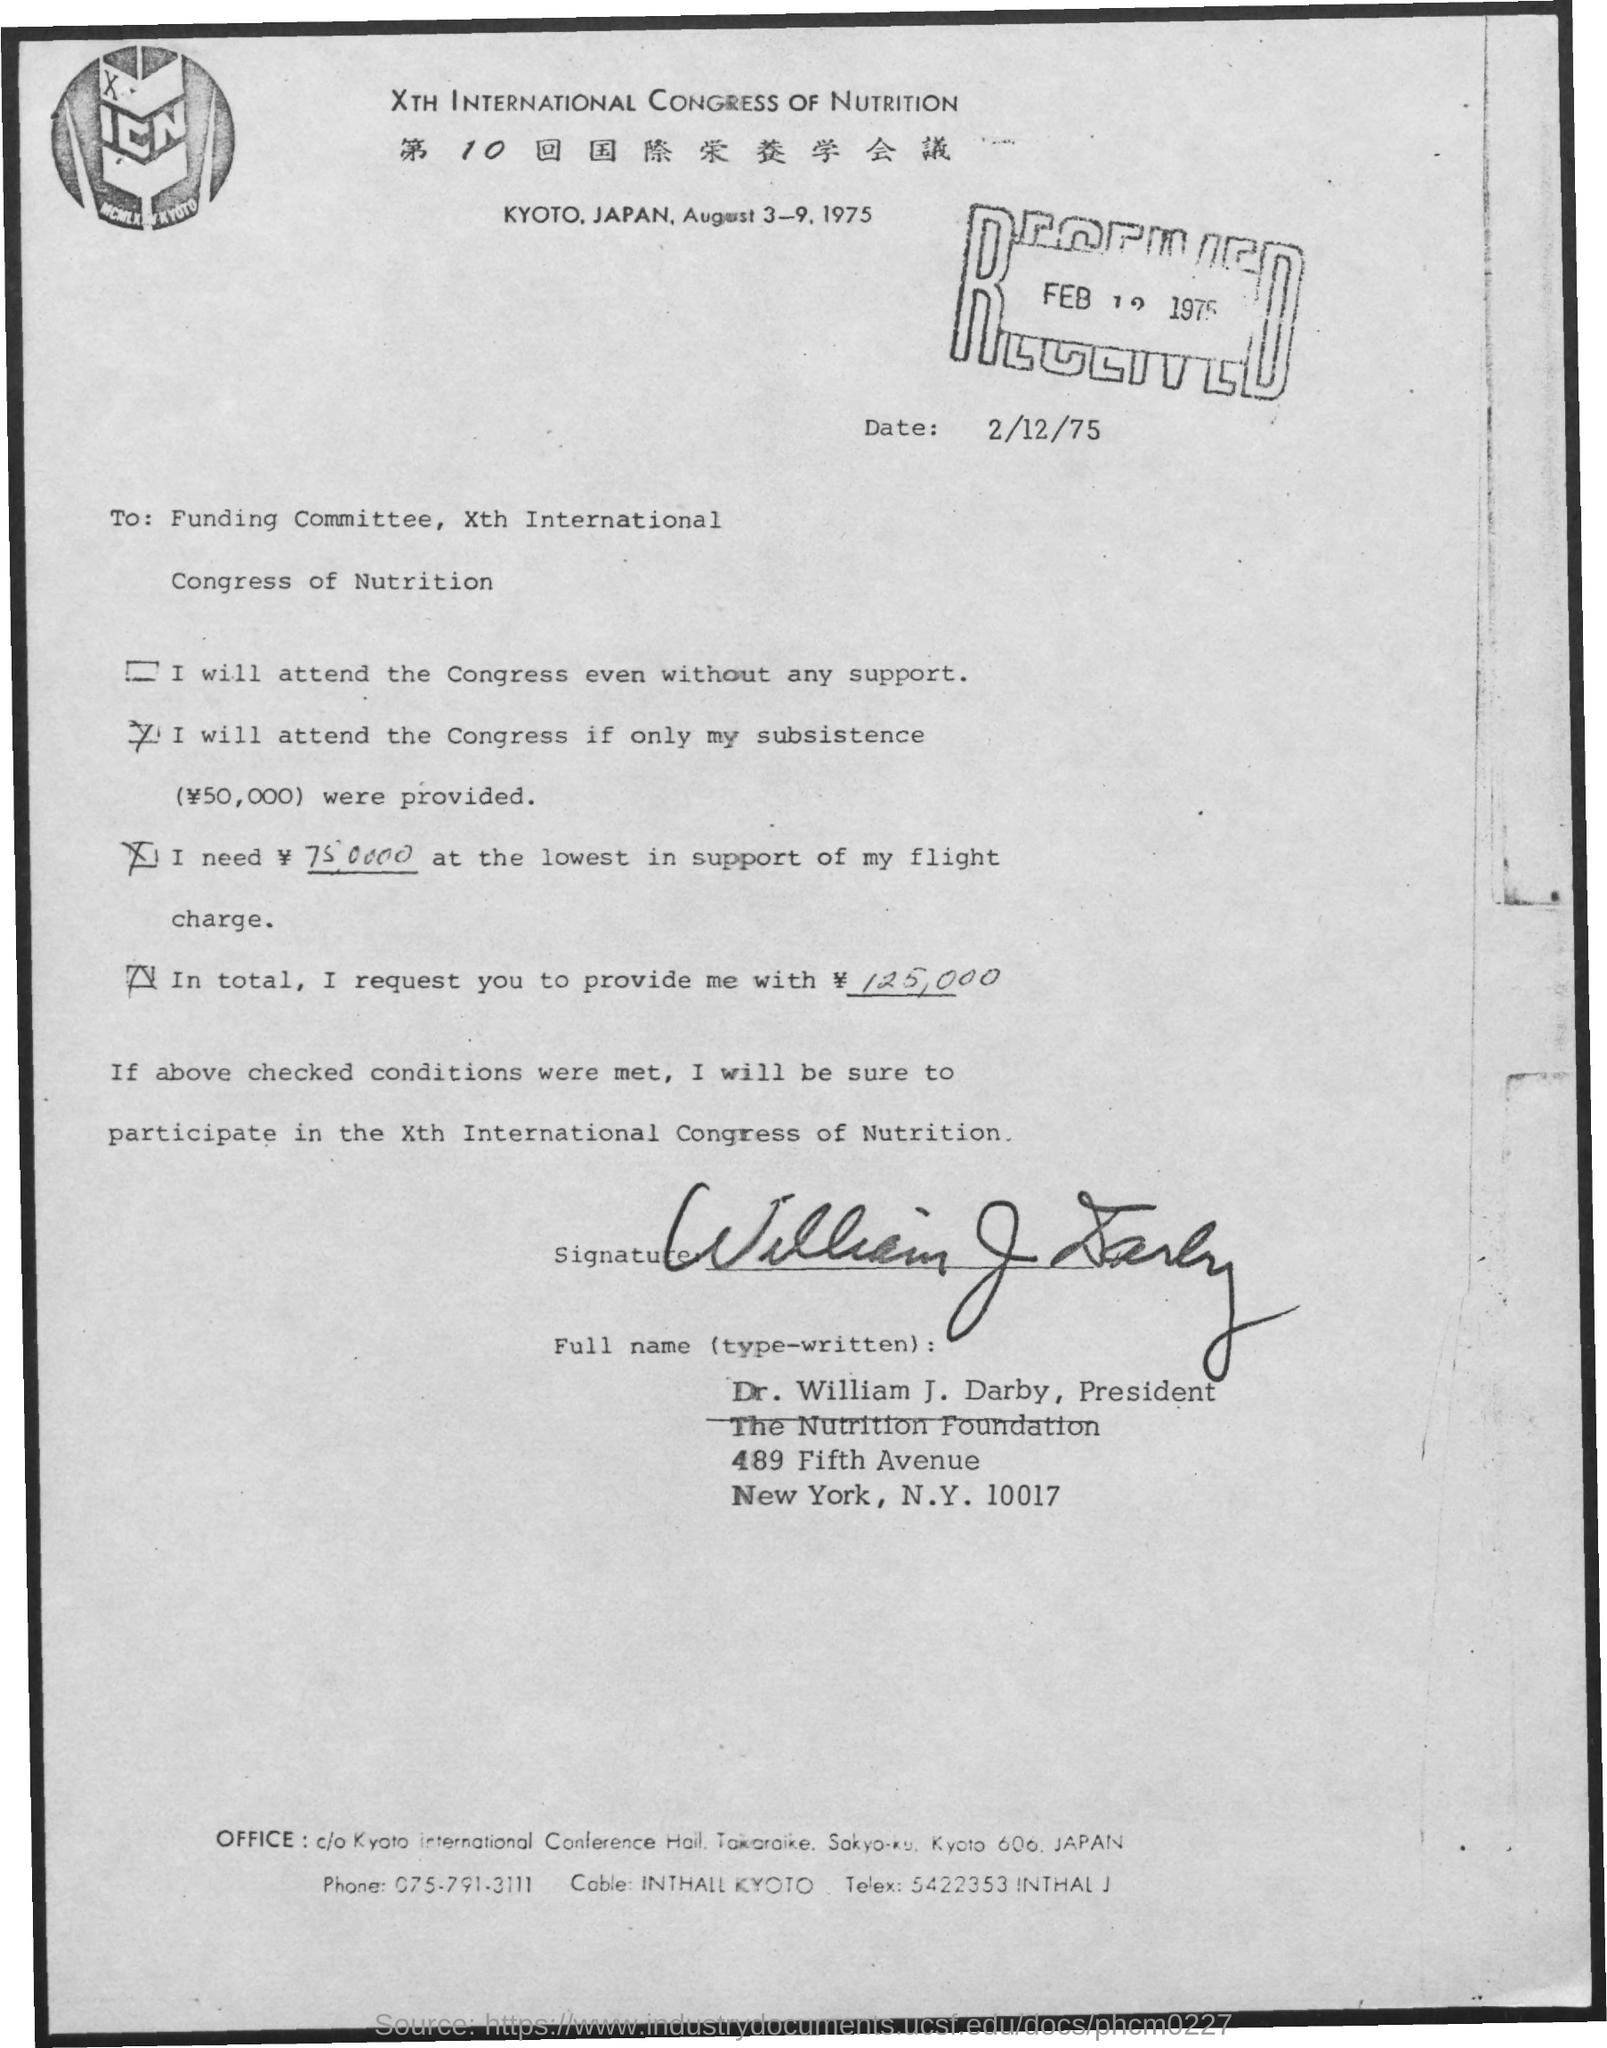What is the name of the congress?
Offer a very short reply. Xth International Congress of Nutrition. Where is the congress going to be held?
Offer a very short reply. KYOTO, JAPAN. When is the Congress going to be held?
Keep it short and to the point. August 3-9, 1975. When is the document dated?
Offer a very short reply. 2/12/75. To whom is the letter addressed?
Your response must be concise. Funding Committee. 